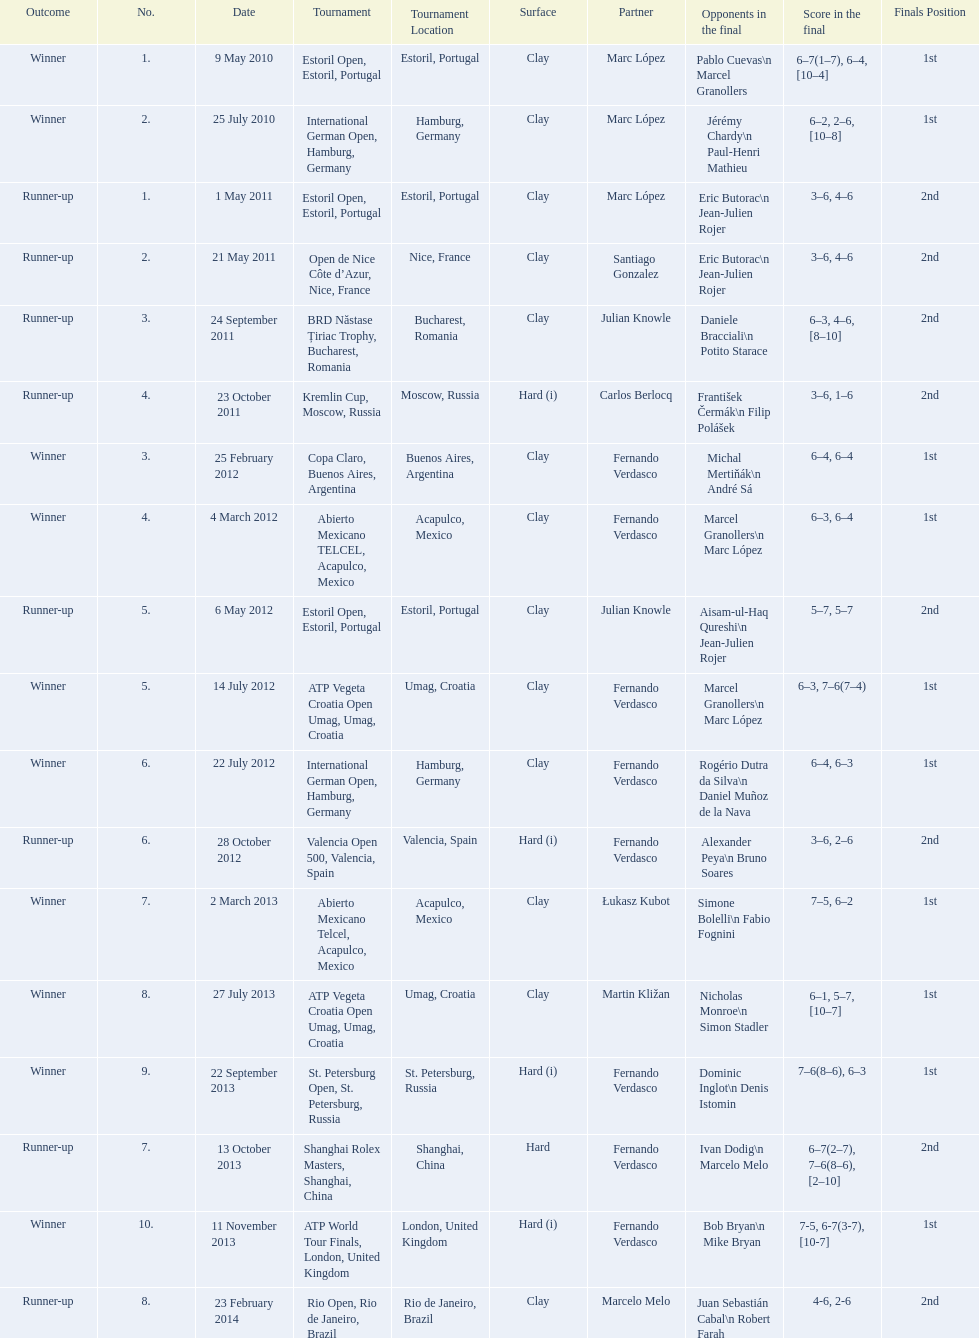How many runner-ups at most are listed? 8. 